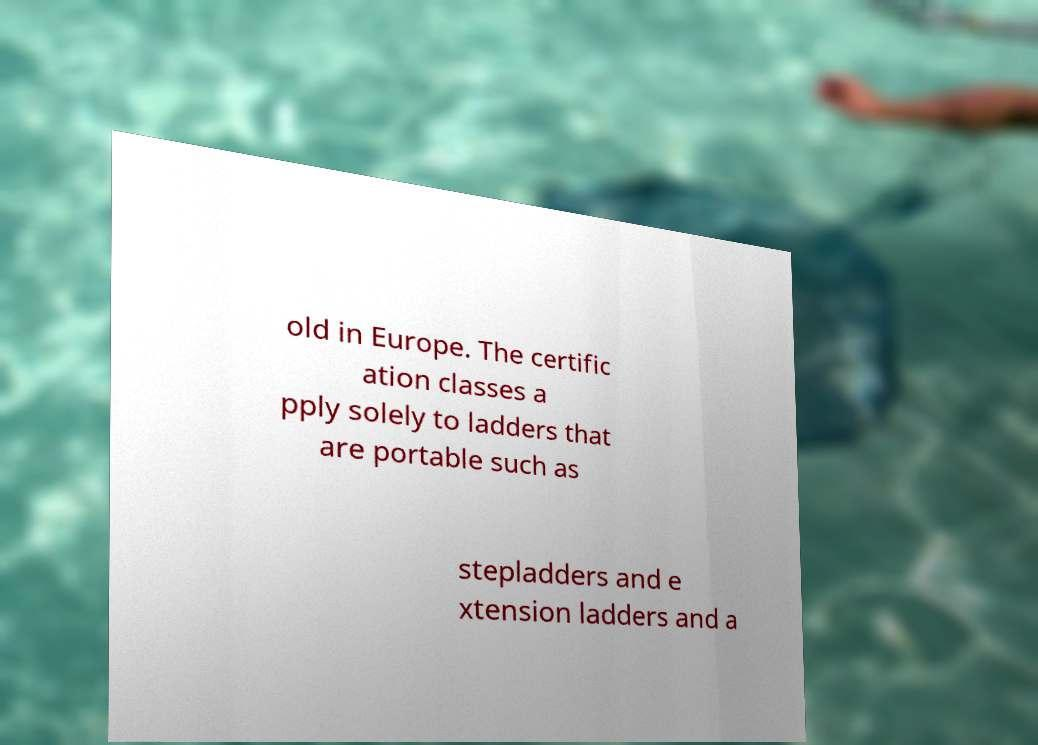Can you accurately transcribe the text from the provided image for me? old in Europe. The certific ation classes a pply solely to ladders that are portable such as stepladders and e xtension ladders and a 